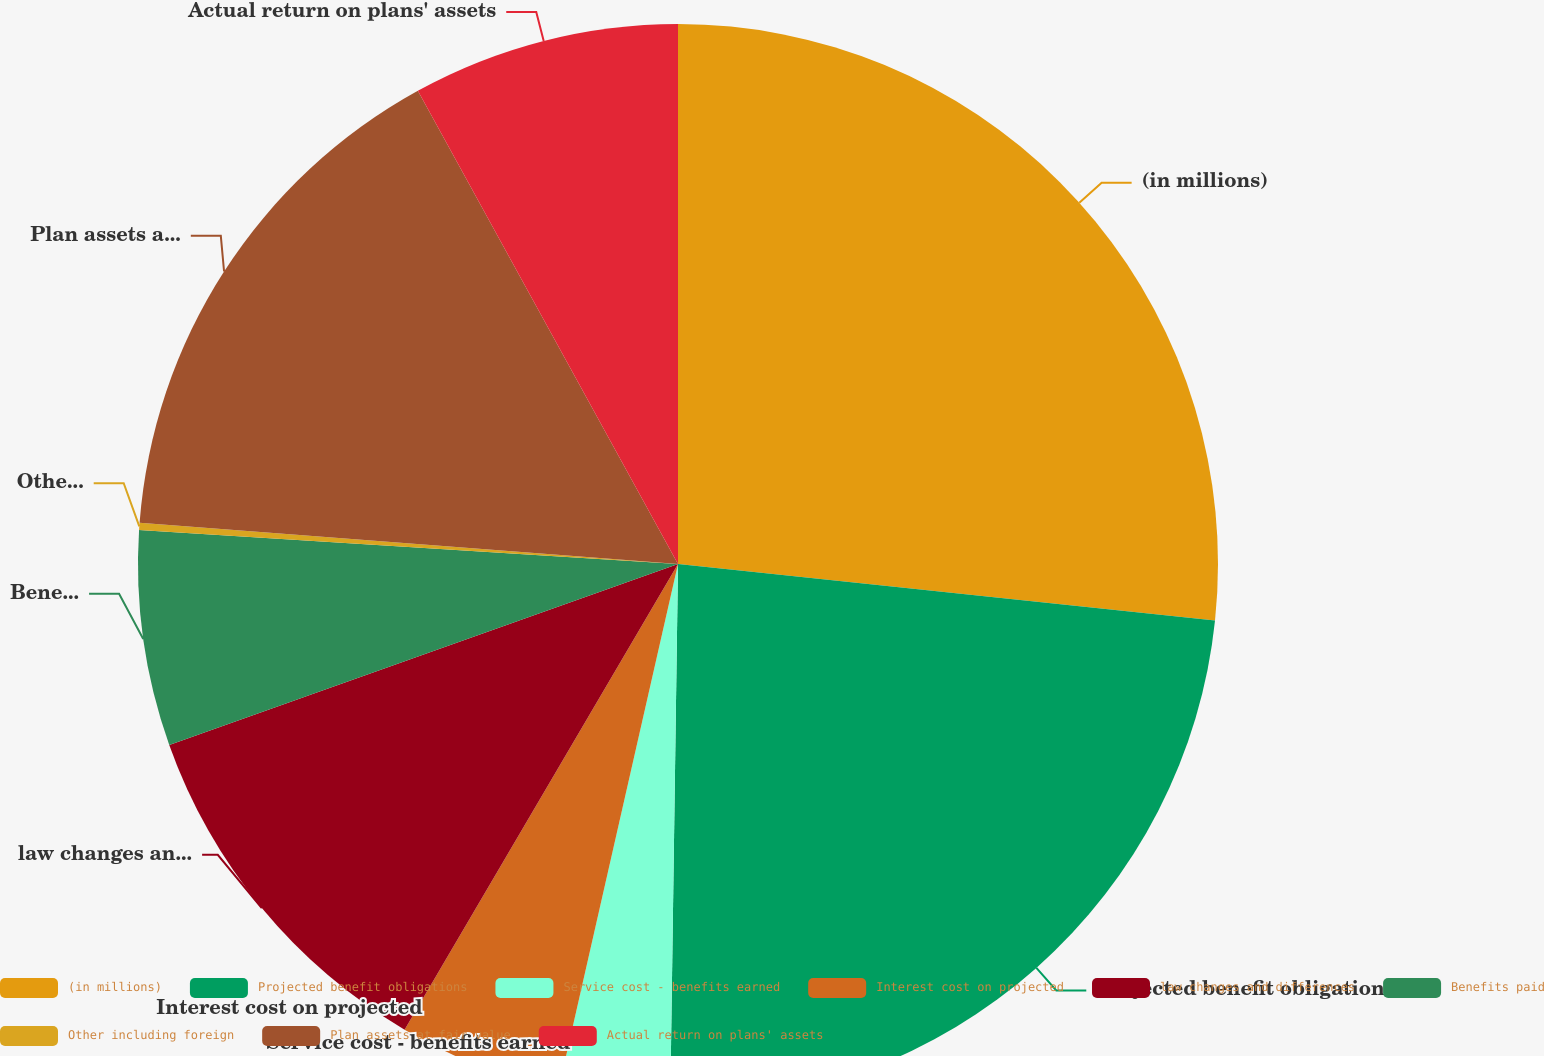Convert chart to OTSL. <chart><loc_0><loc_0><loc_500><loc_500><pie_chart><fcel>(in millions)<fcel>Projected benefit obligations<fcel>Service cost - benefits earned<fcel>Interest cost on projected<fcel>law changes and differences<fcel>Benefits paid<fcel>Other including foreign<fcel>Plan assets at fair value<fcel>Actual return on plans' assets<nl><fcel>26.67%<fcel>23.56%<fcel>3.33%<fcel>4.89%<fcel>11.11%<fcel>6.44%<fcel>0.22%<fcel>15.78%<fcel>8.0%<nl></chart> 